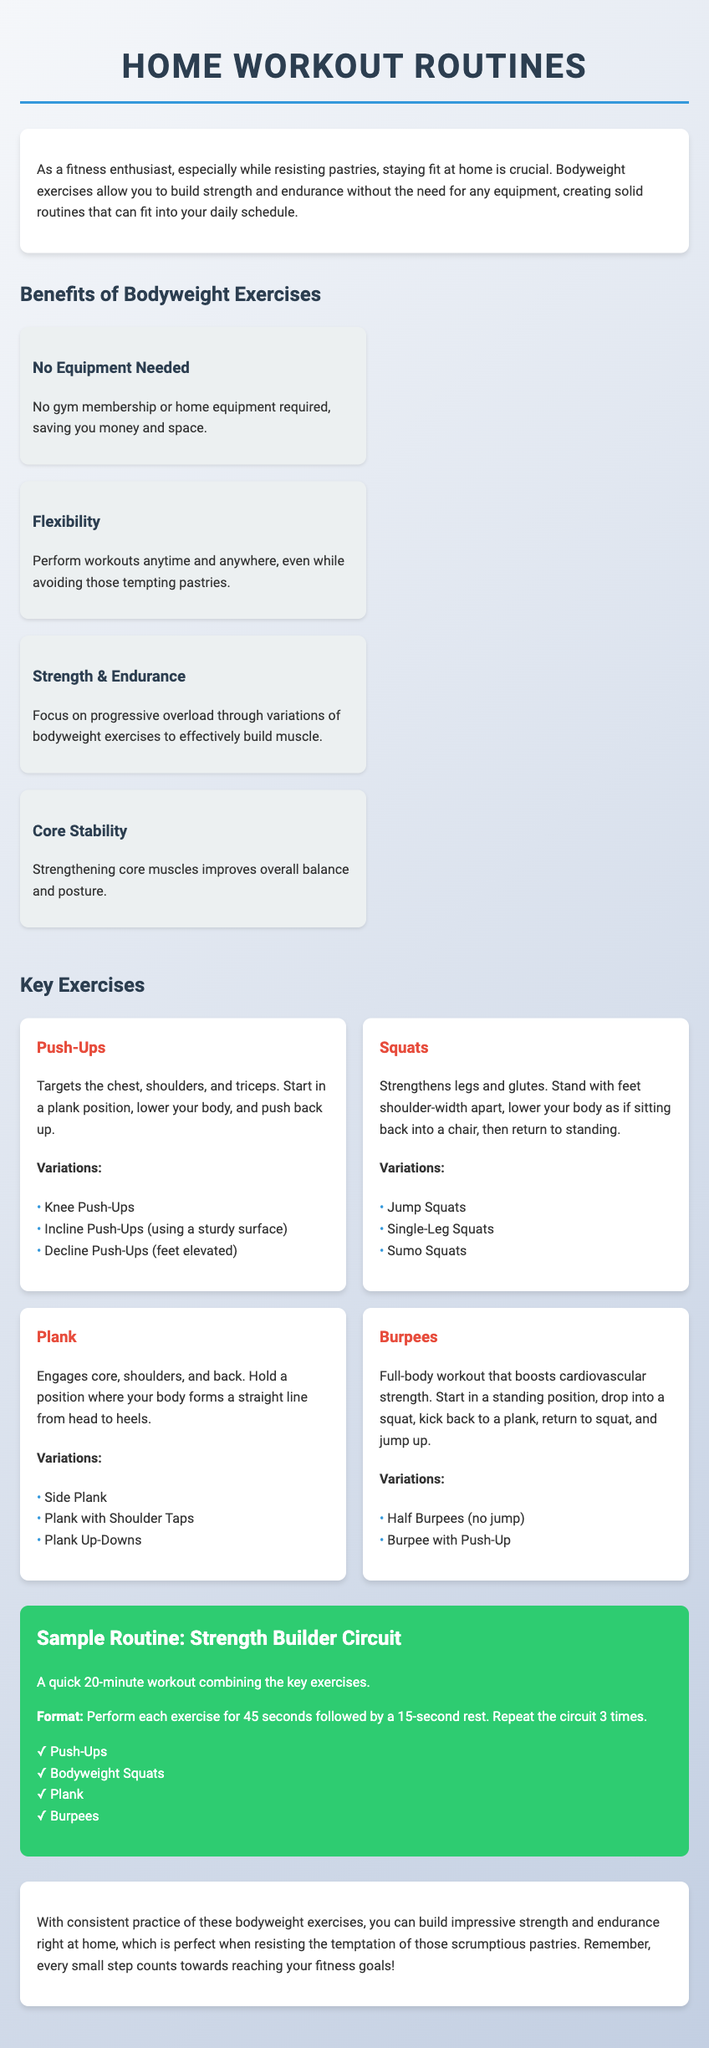What are bodyweight exercises? Bodyweight exercises are workouts that rely on using one's own body weight for resistance rather than external equipment.
Answer: Workouts using body weight How many key exercises are listed in the document? The document mentions four key exercises that are central to the routines.
Answer: Four What is the focus of the workout routine? The routine is designed to focus on building strength and endurance through bodyweight exercises.
Answer: Building strength and endurance What is the duration of the Sample Routine: Strength Builder Circuit workout? The duration of the described circuit workout is explicitly stated in the document.
Answer: 20 minutes What exercise targets the chest, shoulders, and triceps? The specific exercise mentioned in the document that targets these muscle groups is identified clearly.
Answer: Push-Ups What is the format of the Sample Routine? The format outlines how to perform each exercise followed by rest periods, which is detailed in the document.
Answer: 45 seconds on, 15 seconds rest Which exercise is considered a full-body workout? The document uniquely points out one specific exercise that engages the entire body.
Answer: Burpees How many variations are listed for Squats? The document provides the exact number of variations available for this exercise.
Answer: Three What is the color of the routine section in the document? The color associated with the routine section is a prominent feature highlighted in the layout.
Answer: Green 